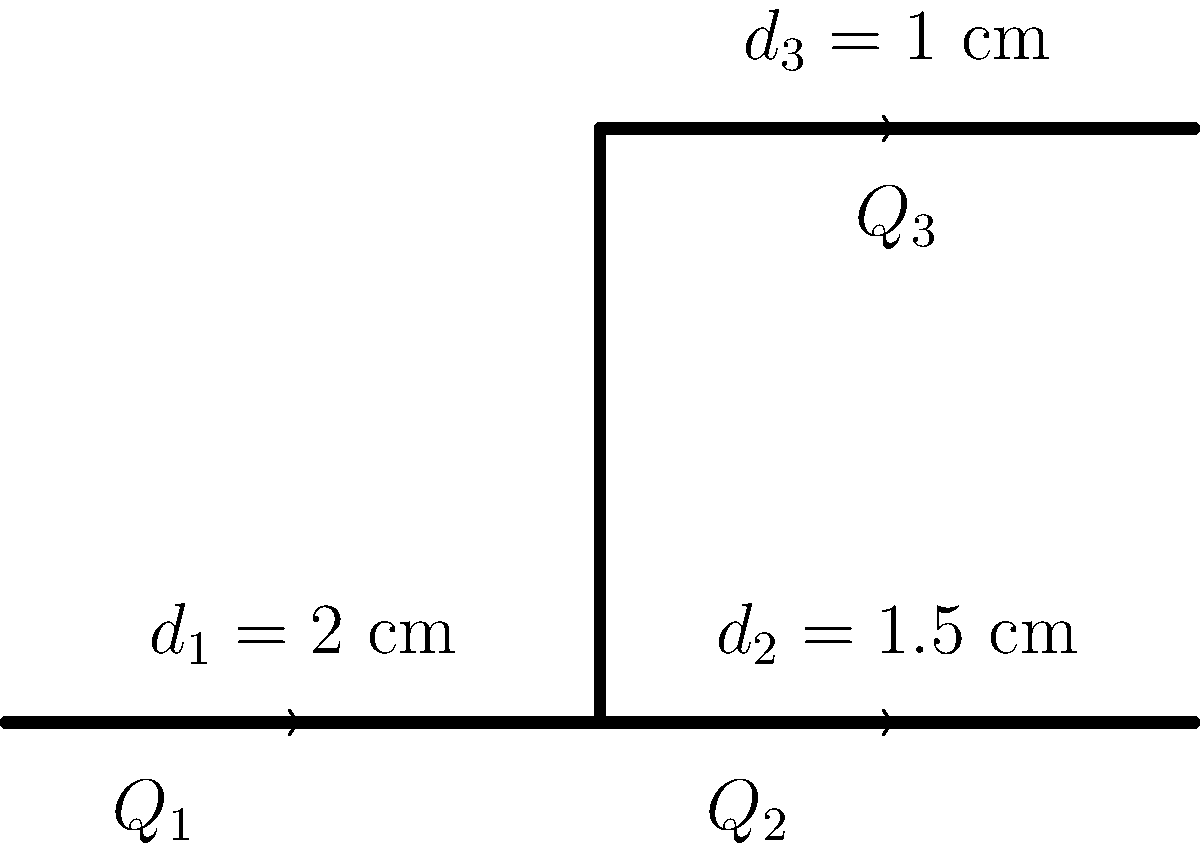In the context of fluid dynamics, consider a pipe network as shown in the diagram. The main pipe with diameter $d_1 = 2$ cm splits into two branches with diameters $d_2 = 1.5$ cm and $d_3 = 1$ cm. If the flow rate in the main pipe is $Q_1 = 100$ cm³/s, calculate the flow rate $Q_3$ in the upper branch. Assume the fluid is incompressible and the flow is steady. How might this scenario relate to the theme of resilience in the face of adversity, as often explored in Elie Wiesel's works? To solve this problem, we'll use the principle of conservation of mass, which is analogous to the preservation of identity and memory in Wiesel's literature. Let's proceed step-by-step:

1) For an incompressible fluid in steady flow, the principle of conservation of mass states that the total flow rate entering a junction must equal the total flow rate leaving it. This can be expressed as:

   $$Q_1 = Q_2 + Q_3$$

2) We know $Q_1 = 100$ cm³/s, but we need to find $Q_3$. To do this, we can use the continuity equation, which states that the product of velocity and cross-sectional area remains constant in a continuous flow:

   $$A_1v_1 = A_2v_2 + A_3v_3$$

3) The cross-sectional area of a circular pipe is $A = \frac{\pi d^2}{4}$. Let's calculate the areas:

   $$A_1 = \frac{\pi (2\text{ cm})^2}{4} = \pi \text{ cm}^2$$
   $$A_2 = \frac{\pi (1.5\text{ cm})^2}{4} = \frac{9\pi}{16} \text{ cm}^2$$
   $$A_3 = \frac{\pi (1\text{ cm})^2}{4} = \frac{\pi}{4} \text{ cm}^2$$

4) The flow rate is the product of velocity and area. So, $Q = Av$. We can rewrite our equation:

   $$Q_1 = Q_2 + Q_3$$
   $$A_1v_1 = A_2v_2 + A_3v_3$$

5) Now, let's express $v_2$ in terms of $v_1$:

   $$v_2 = v_1 \cdot \frac{A_1}{A_2} = v_1 \cdot \frac{\pi}{9\pi/16} = \frac{16}{9}v_1$$

6) Similarly for $v_3$:

   $$v_3 = v_1 \cdot \frac{A_1}{A_3} = v_1 \cdot \frac{\pi}{\pi/4} = 4v_1$$

7) Substituting these back into our equation:

   $$Q_1 = A_2(\frac{16}{9}v_1) + A_3(4v_1)$$
   $$100 = \frac{9\pi}{16} \cdot \frac{16}{9}v_1 + \frac{\pi}{4} \cdot 4v_1$$
   $$100 = \pi v_1 + \pi v_1 = 2\pi v_1$$

8) Solving for $v_1$:

   $$v_1 = \frac{100}{2\pi} = \frac{50}{\pi} \text{ cm/s}$$

9) Now we can calculate $Q_3$:

   $$Q_3 = A_3v_3 = \frac{\pi}{4} \cdot 4 \cdot \frac{50}{\pi} = 50 \text{ cm³/s}$$

This solution demonstrates how, even when faced with division and constraints (like the splitting of the pipe), there's a way to maintain continuity and balance - a theme often explored in Wiesel's work about preserving identity and culture in the face of adversity.
Answer: 50 cm³/s 